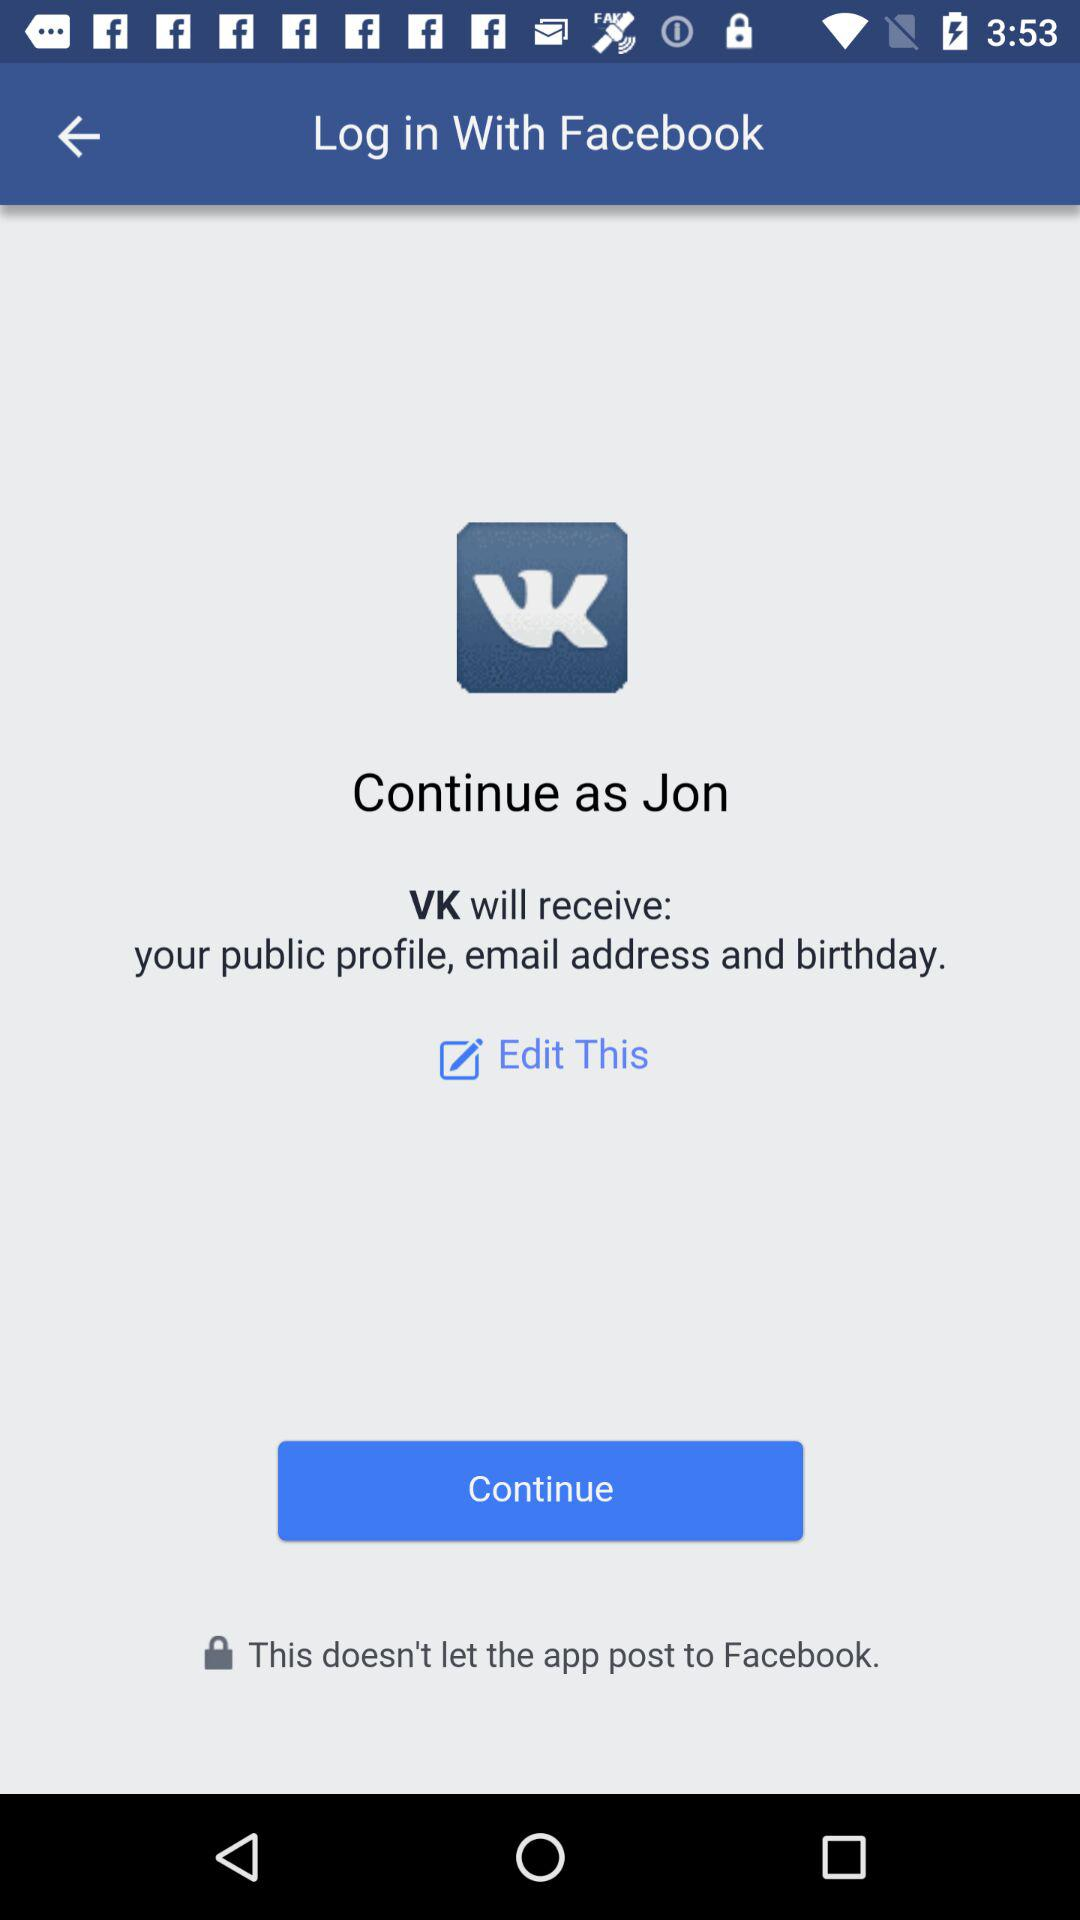Through what application is the person logging in? The application is "Facebook". 